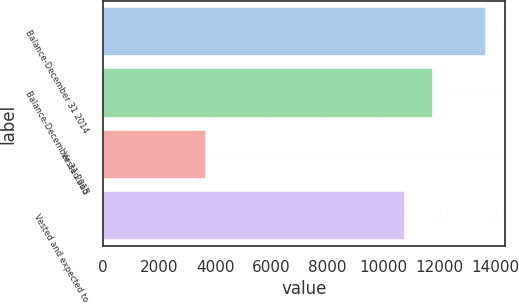Convert chart. <chart><loc_0><loc_0><loc_500><loc_500><bar_chart><fcel>Balance-December 31 2014<fcel>Balance-December 31 2015<fcel>Vested and<fcel>Vested and expected to<nl><fcel>13654<fcel>11782.2<fcel>3692<fcel>10786<nl></chart> 